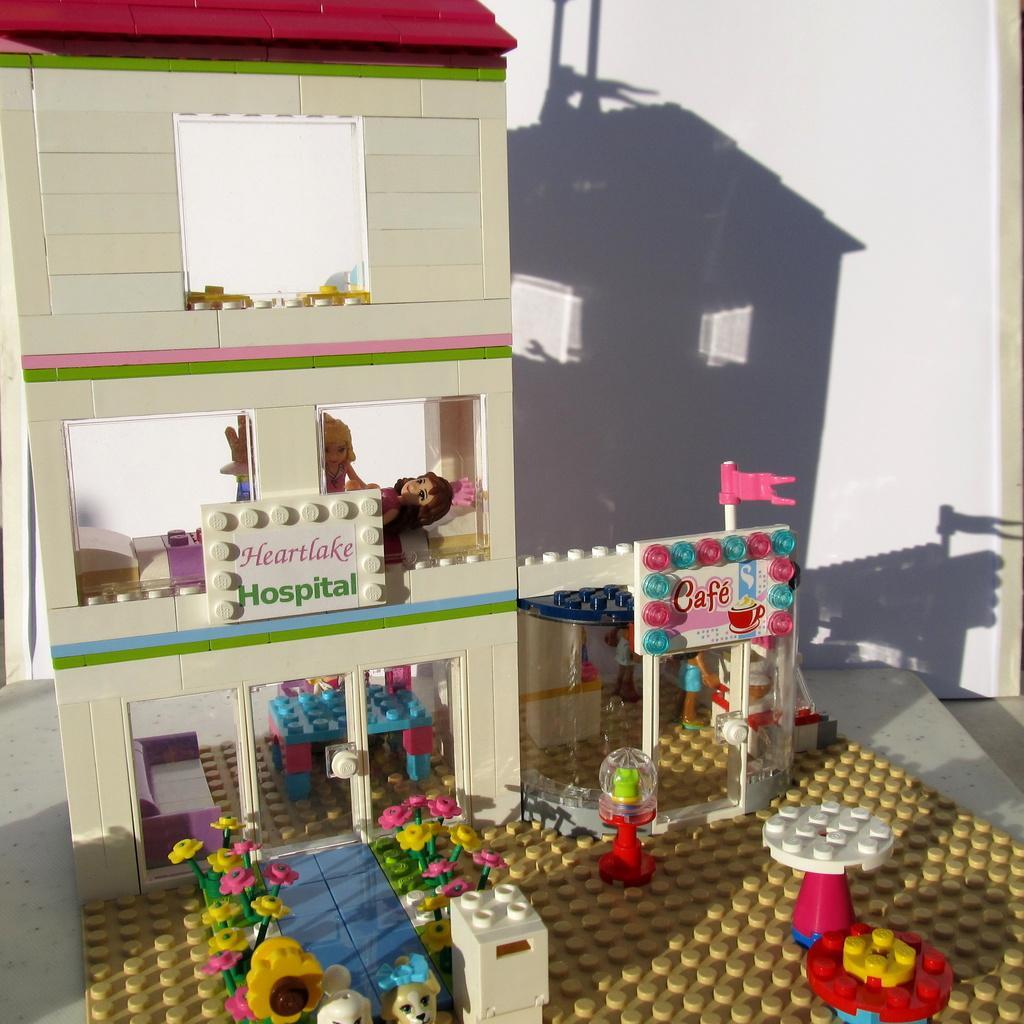How would you summarize this image in a sentence or two? In this picture we can see a building, toys, tables, flowers, flag made of Lego. 